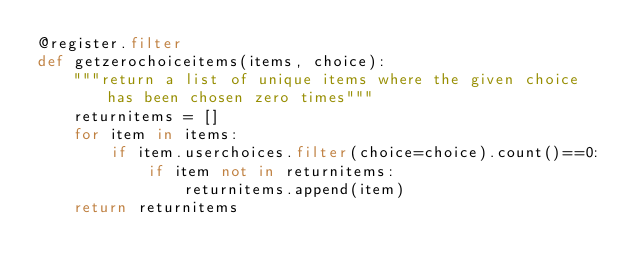Convert code to text. <code><loc_0><loc_0><loc_500><loc_500><_Python_>@register.filter
def getzerochoiceitems(items, choice):
    """return a list of unique items where the given choice has been chosen zero times"""
    returnitems = []
    for item in items:
        if item.userchoices.filter(choice=choice).count()==0:
            if item not in returnitems:
                returnitems.append(item)
    return returnitems

</code> 